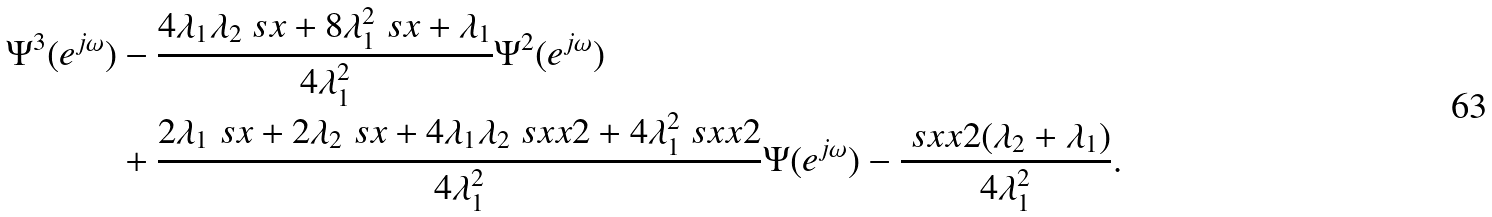<formula> <loc_0><loc_0><loc_500><loc_500>\Psi ^ { 3 } ( e ^ { j \omega } ) & - \frac { 4 \lambda _ { 1 } \lambda _ { 2 } \ s x + 8 \lambda _ { 1 } ^ { 2 } \ s x + \lambda _ { 1 } } { 4 \lambda _ { 1 } ^ { 2 } } \Psi ^ { 2 } ( e ^ { j \omega } ) \\ & + \frac { 2 \lambda _ { 1 } \ s x + 2 \lambda _ { 2 } \ s x + 4 \lambda _ { 1 } \lambda _ { 2 } \ s x x { 2 } + 4 \lambda _ { 1 } ^ { 2 } \ s x x { 2 } } { 4 \lambda _ { 1 } ^ { 2 } } \Psi ( e ^ { j \omega } ) - \frac { \ s x x { 2 } ( \lambda _ { 2 } + \lambda _ { 1 } ) } { 4 \lambda _ { 1 } ^ { 2 } } .</formula> 